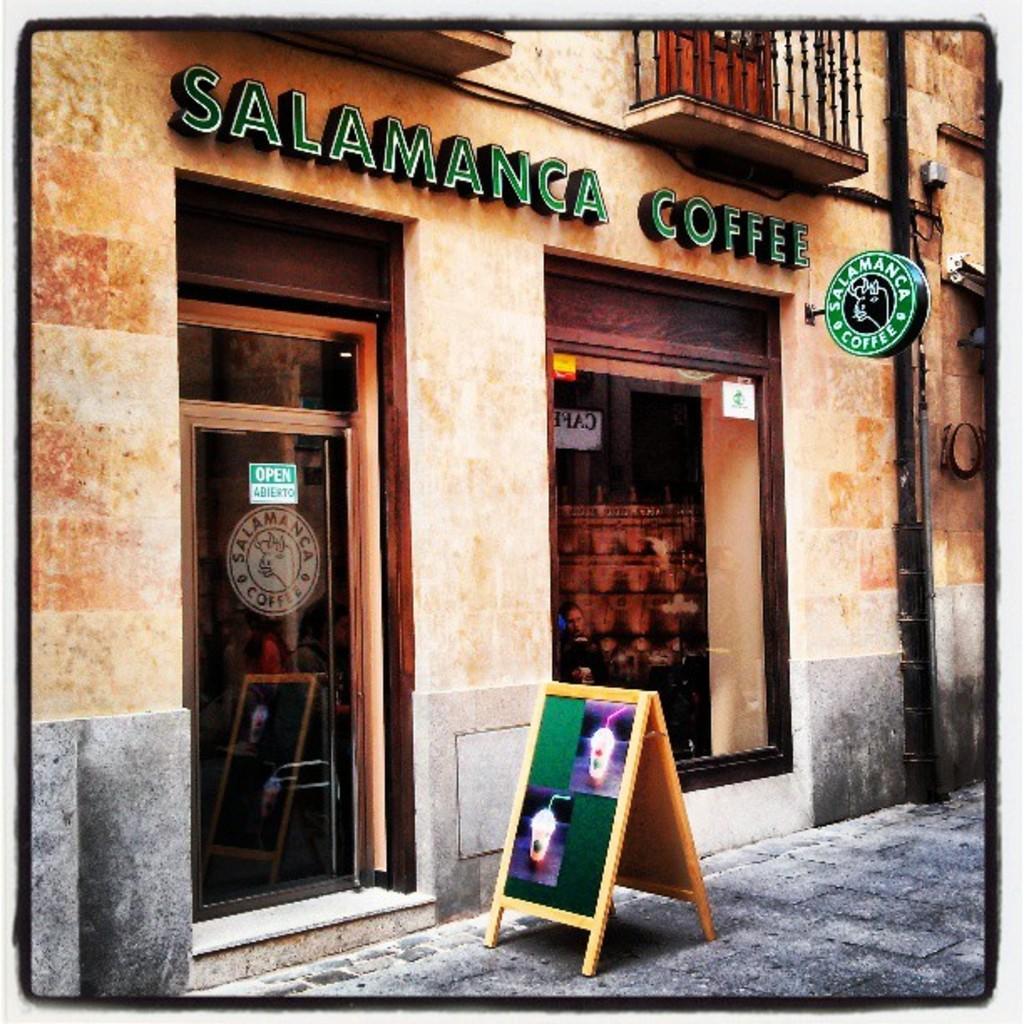What coffee shop has green lettering on the outside of the building?
Your answer should be compact. Salamanca. 